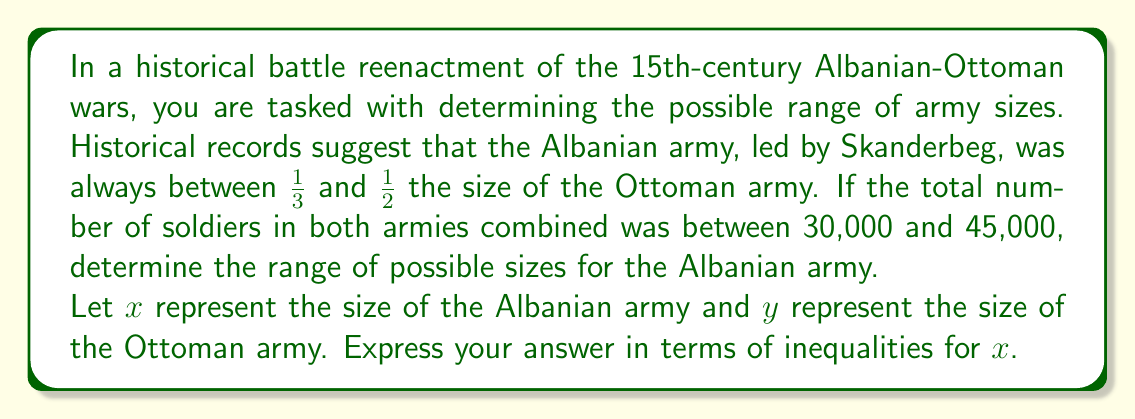Teach me how to tackle this problem. Let's approach this step-by-step:

1) We know that the Albanian army size ($x$) is between 1/3 and 1/2 of the Ottoman army size ($y$):

   $$\frac{1}{3}y \leq x \leq \frac{1}{2}y$$

2) We also know that the total number of soldiers is between 30,000 and 45,000:

   $$30000 \leq x + y \leq 45000$$

3) To find the minimum possible size of the Albanian army, we consider the case where $x = \frac{1}{3}y$ and the total is 30,000:

   $$x + y = 30000$$
   $$\frac{1}{3}y + y = 30000$$
   $$\frac{4}{3}y = 30000$$
   $$y = 22500$$
   $$x = \frac{1}{3}y = 7500$$

4) For the maximum size, we consider $x = \frac{1}{2}y$ and the total is 45,000:

   $$x + y = 45000$$
   $$\frac{1}{2}y + y = 45000$$
   $$\frac{3}{2}y = 45000$$
   $$y = 30000$$
   $$x = \frac{1}{2}y = 15000$$

5) Therefore, the range of possible sizes for the Albanian army is:

   $$7500 \leq x \leq 15000$$
Answer: $$7500 \leq x \leq 15000$$ 